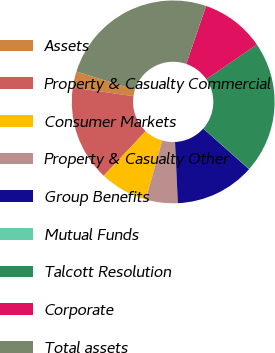<chart> <loc_0><loc_0><loc_500><loc_500><pie_chart><fcel>Assets<fcel>Property & Casualty Commercial<fcel>Consumer Markets<fcel>Property & Casualty Other<fcel>Group Benefits<fcel>Mutual Funds<fcel>Talcott Resolution<fcel>Corporate<fcel>Total assets<nl><fcel>2.57%<fcel>15.26%<fcel>7.64%<fcel>5.1%<fcel>12.72%<fcel>0.03%<fcel>21.07%<fcel>10.18%<fcel>25.42%<nl></chart> 